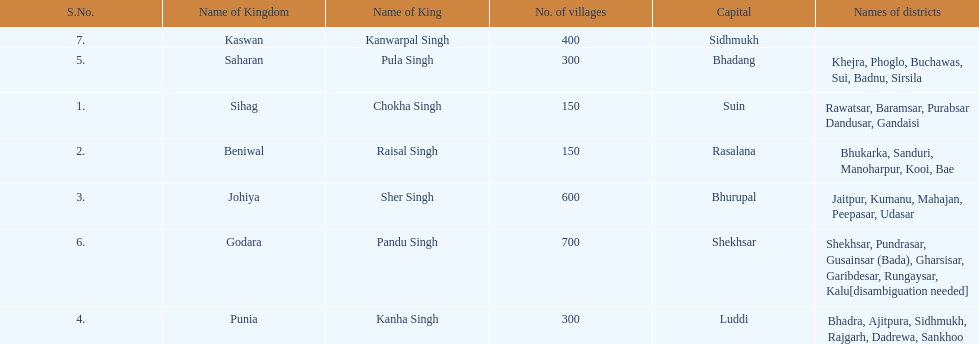Which kingdom contained the second most villages, next only to godara? Johiya. 